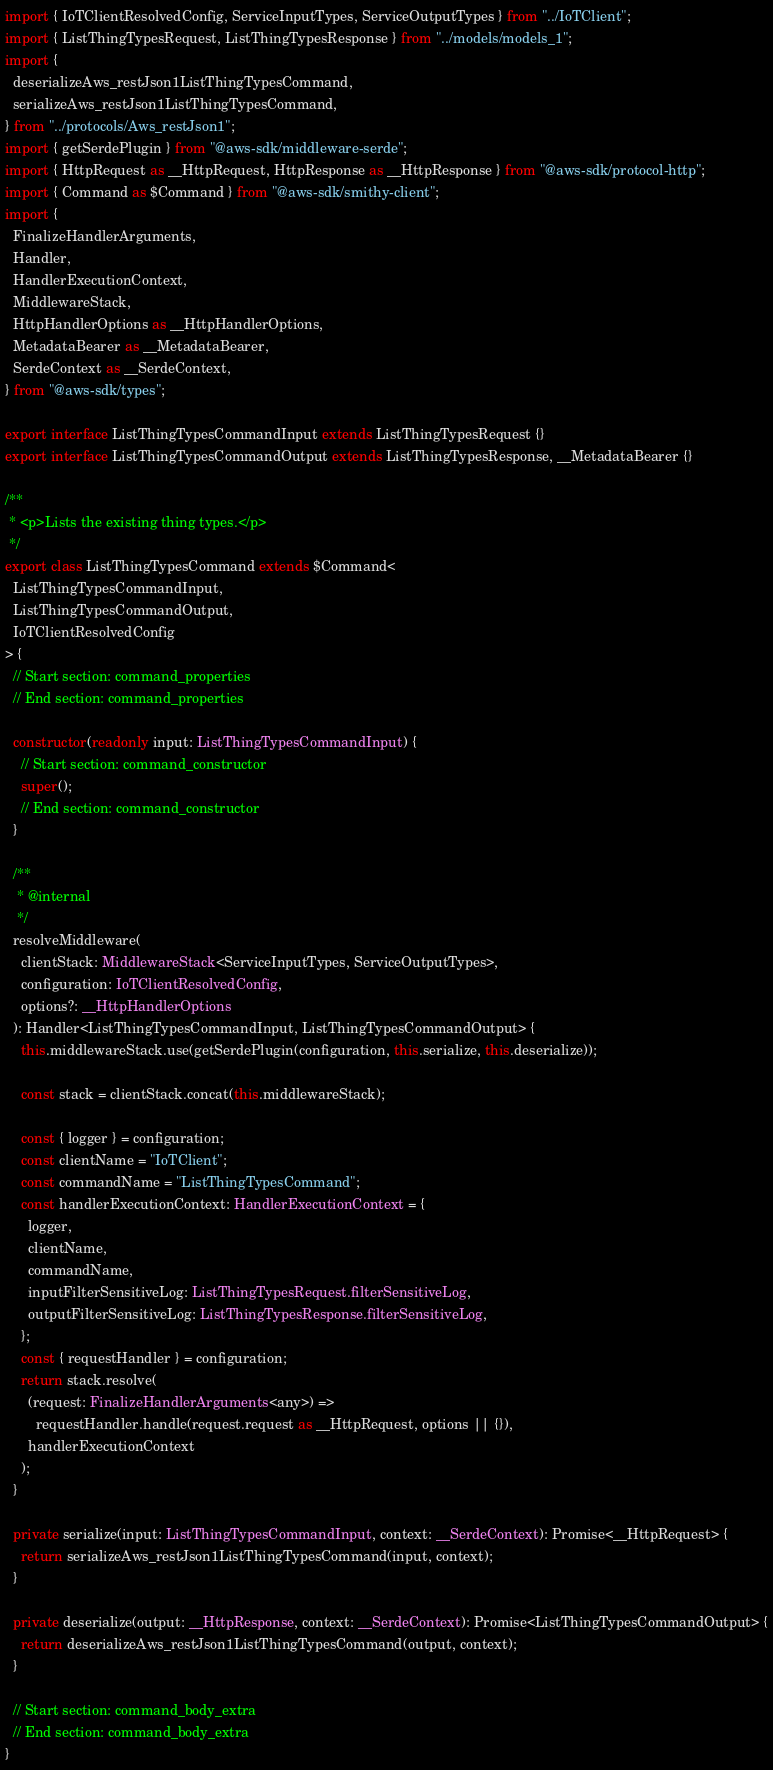Convert code to text. <code><loc_0><loc_0><loc_500><loc_500><_TypeScript_>import { IoTClientResolvedConfig, ServiceInputTypes, ServiceOutputTypes } from "../IoTClient";
import { ListThingTypesRequest, ListThingTypesResponse } from "../models/models_1";
import {
  deserializeAws_restJson1ListThingTypesCommand,
  serializeAws_restJson1ListThingTypesCommand,
} from "../protocols/Aws_restJson1";
import { getSerdePlugin } from "@aws-sdk/middleware-serde";
import { HttpRequest as __HttpRequest, HttpResponse as __HttpResponse } from "@aws-sdk/protocol-http";
import { Command as $Command } from "@aws-sdk/smithy-client";
import {
  FinalizeHandlerArguments,
  Handler,
  HandlerExecutionContext,
  MiddlewareStack,
  HttpHandlerOptions as __HttpHandlerOptions,
  MetadataBearer as __MetadataBearer,
  SerdeContext as __SerdeContext,
} from "@aws-sdk/types";

export interface ListThingTypesCommandInput extends ListThingTypesRequest {}
export interface ListThingTypesCommandOutput extends ListThingTypesResponse, __MetadataBearer {}

/**
 * <p>Lists the existing thing types.</p>
 */
export class ListThingTypesCommand extends $Command<
  ListThingTypesCommandInput,
  ListThingTypesCommandOutput,
  IoTClientResolvedConfig
> {
  // Start section: command_properties
  // End section: command_properties

  constructor(readonly input: ListThingTypesCommandInput) {
    // Start section: command_constructor
    super();
    // End section: command_constructor
  }

  /**
   * @internal
   */
  resolveMiddleware(
    clientStack: MiddlewareStack<ServiceInputTypes, ServiceOutputTypes>,
    configuration: IoTClientResolvedConfig,
    options?: __HttpHandlerOptions
  ): Handler<ListThingTypesCommandInput, ListThingTypesCommandOutput> {
    this.middlewareStack.use(getSerdePlugin(configuration, this.serialize, this.deserialize));

    const stack = clientStack.concat(this.middlewareStack);

    const { logger } = configuration;
    const clientName = "IoTClient";
    const commandName = "ListThingTypesCommand";
    const handlerExecutionContext: HandlerExecutionContext = {
      logger,
      clientName,
      commandName,
      inputFilterSensitiveLog: ListThingTypesRequest.filterSensitiveLog,
      outputFilterSensitiveLog: ListThingTypesResponse.filterSensitiveLog,
    };
    const { requestHandler } = configuration;
    return stack.resolve(
      (request: FinalizeHandlerArguments<any>) =>
        requestHandler.handle(request.request as __HttpRequest, options || {}),
      handlerExecutionContext
    );
  }

  private serialize(input: ListThingTypesCommandInput, context: __SerdeContext): Promise<__HttpRequest> {
    return serializeAws_restJson1ListThingTypesCommand(input, context);
  }

  private deserialize(output: __HttpResponse, context: __SerdeContext): Promise<ListThingTypesCommandOutput> {
    return deserializeAws_restJson1ListThingTypesCommand(output, context);
  }

  // Start section: command_body_extra
  // End section: command_body_extra
}
</code> 